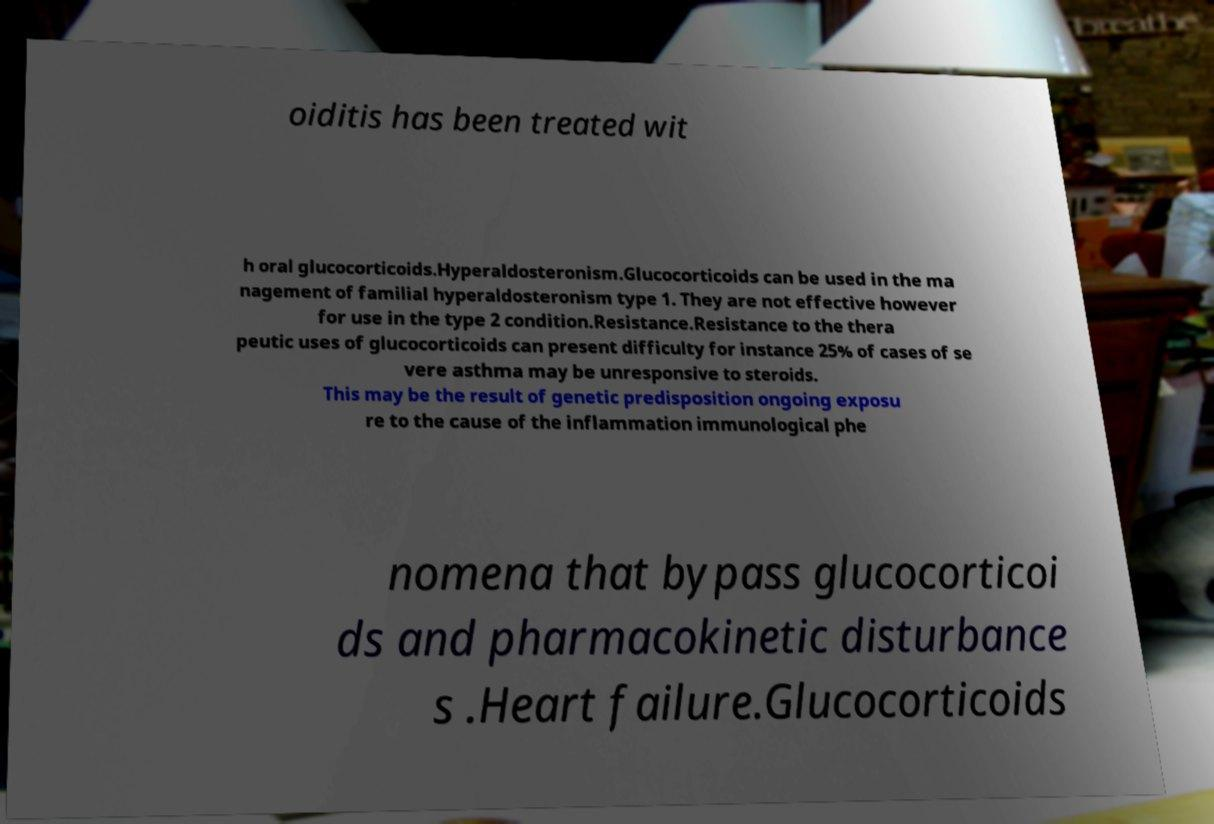There's text embedded in this image that I need extracted. Can you transcribe it verbatim? oiditis has been treated wit h oral glucocorticoids.Hyperaldosteronism.Glucocorticoids can be used in the ma nagement of familial hyperaldosteronism type 1. They are not effective however for use in the type 2 condition.Resistance.Resistance to the thera peutic uses of glucocorticoids can present difficulty for instance 25% of cases of se vere asthma may be unresponsive to steroids. This may be the result of genetic predisposition ongoing exposu re to the cause of the inflammation immunological phe nomena that bypass glucocorticoi ds and pharmacokinetic disturbance s .Heart failure.Glucocorticoids 